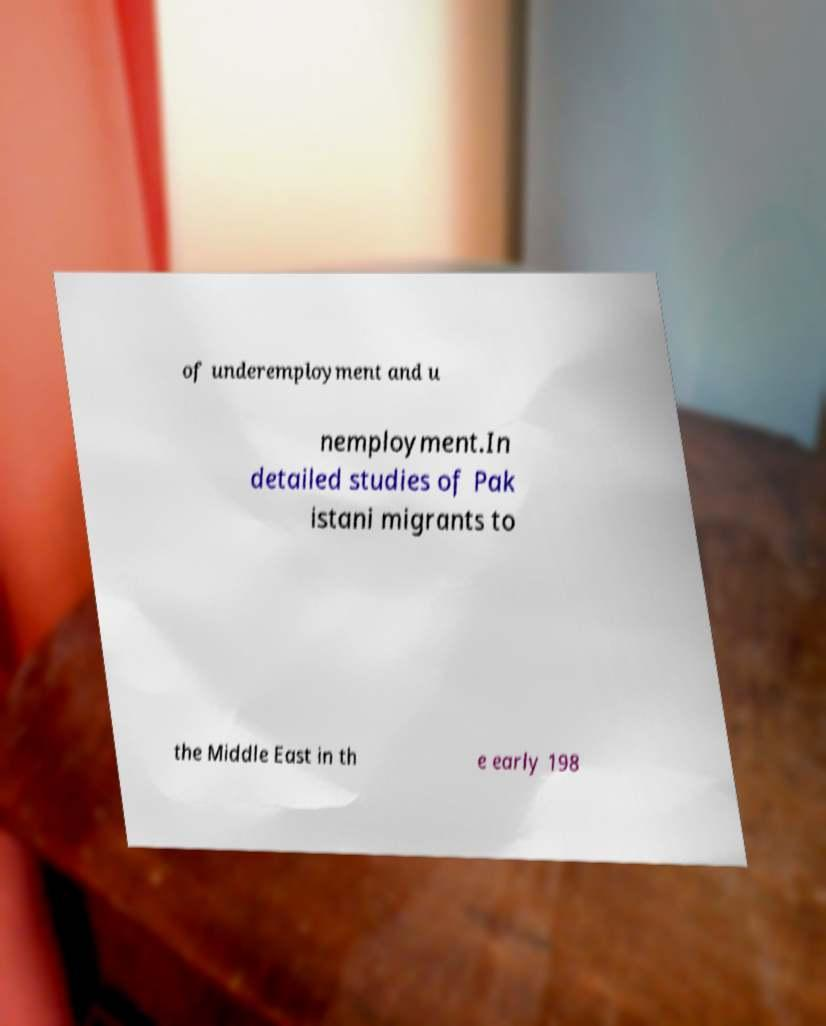Could you assist in decoding the text presented in this image and type it out clearly? of underemployment and u nemployment.In detailed studies of Pak istani migrants to the Middle East in th e early 198 